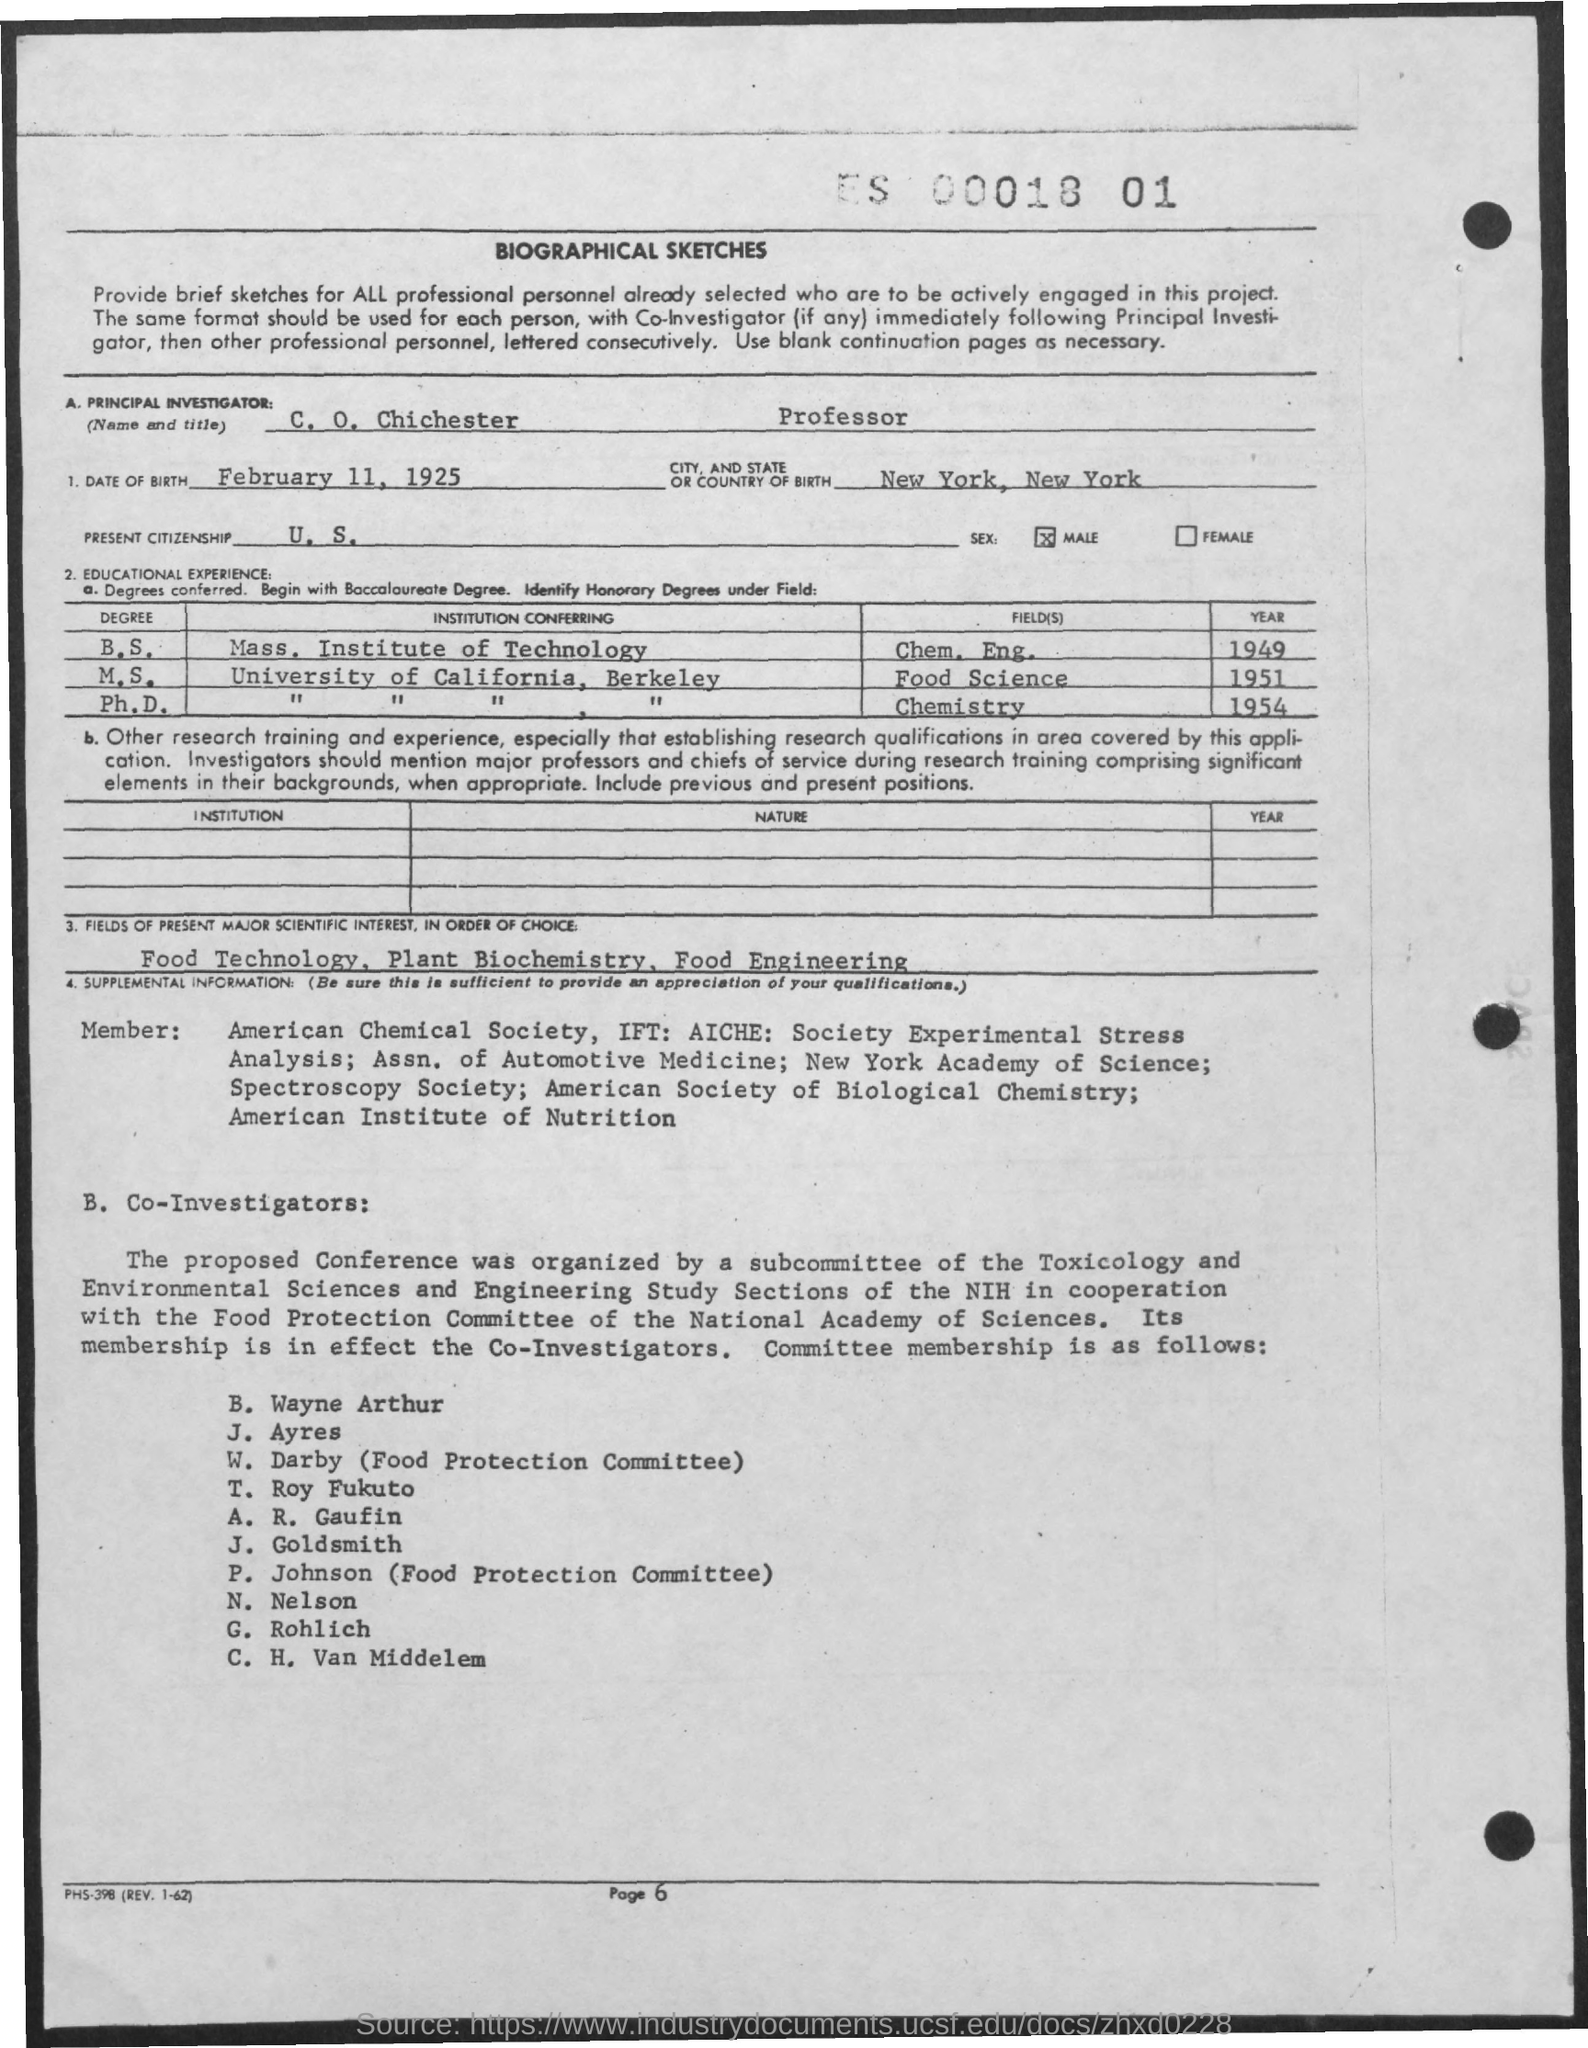What is the name of principal investigator?
Your answer should be compact. C. O. Chichester. What is the title of principal investigator?
Give a very brief answer. Professor. What is the date of birth of principal investigator?
Your answer should be very brief. February 11, 1925. What is the city, and state of birth of the principal investigator?
Your answer should be very brief. New York, New York. What is the sex of principal investigator ?
Give a very brief answer. Male. In which year did the principal investigator receive his bachelors degree?
Make the answer very short. 1949. In which Field did Principal investigator do his masters in?
Your answer should be compact. Food Science. In which year did Principal Investigator complete his Ph.D?
Keep it short and to the point. 1954. 